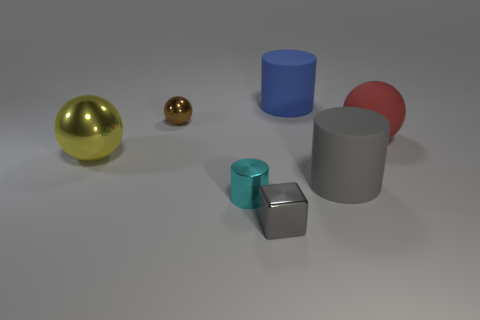Subtract all large cylinders. How many cylinders are left? 1 Add 1 tiny shiny things. How many objects exist? 8 Subtract all yellow balls. How many balls are left? 2 Subtract all cylinders. How many objects are left? 4 Subtract 2 balls. How many balls are left? 1 Add 6 gray metallic cubes. How many gray metallic cubes are left? 7 Add 6 matte objects. How many matte objects exist? 9 Subtract 0 green blocks. How many objects are left? 7 Subtract all green balls. Subtract all yellow cylinders. How many balls are left? 3 Subtract all green cylinders. How many red balls are left? 1 